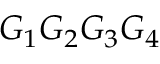Convert formula to latex. <formula><loc_0><loc_0><loc_500><loc_500>G _ { 1 } G _ { 2 } G _ { 3 } G _ { 4 }</formula> 